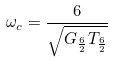Convert formula to latex. <formula><loc_0><loc_0><loc_500><loc_500>\omega _ { c } = \frac { 6 } { \sqrt { G _ { \frac { 6 } { 2 } } T _ { \frac { 6 } { 2 } } } }</formula> 